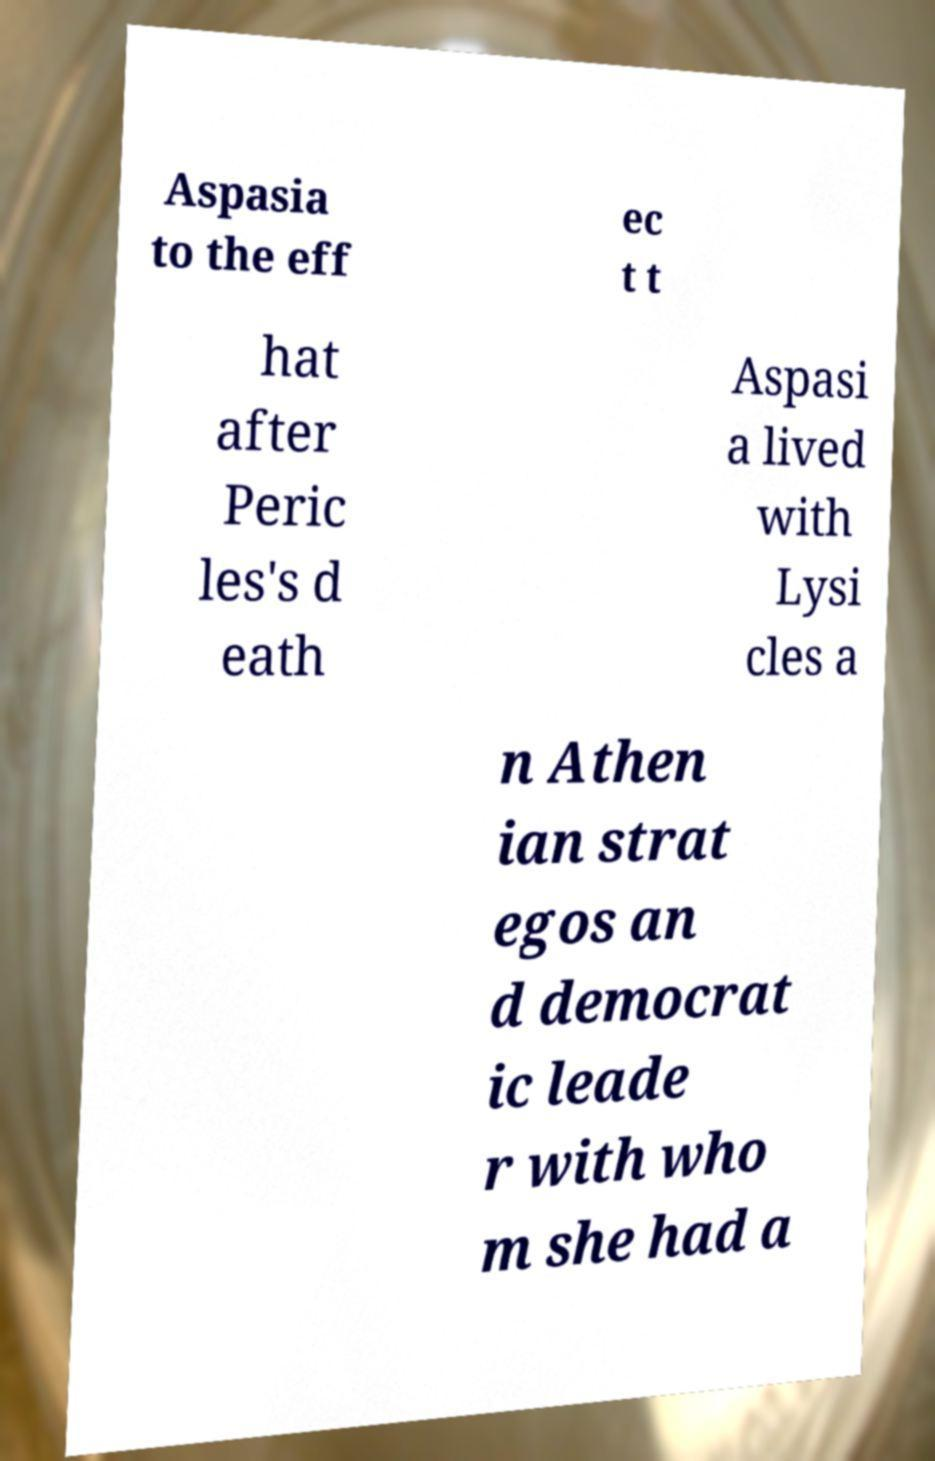There's text embedded in this image that I need extracted. Can you transcribe it verbatim? Aspasia to the eff ec t t hat after Peric les's d eath Aspasi a lived with Lysi cles a n Athen ian strat egos an d democrat ic leade r with who m she had a 